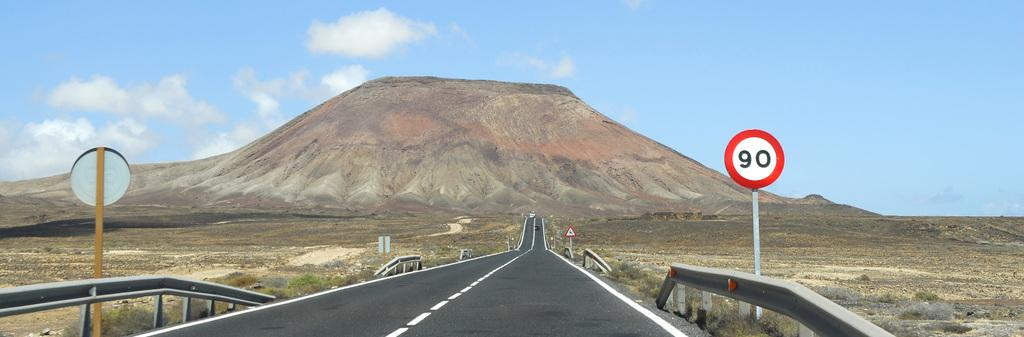Provide a one-sentence caption for the provided image. empty road with no cars insight and a street sign 90. 